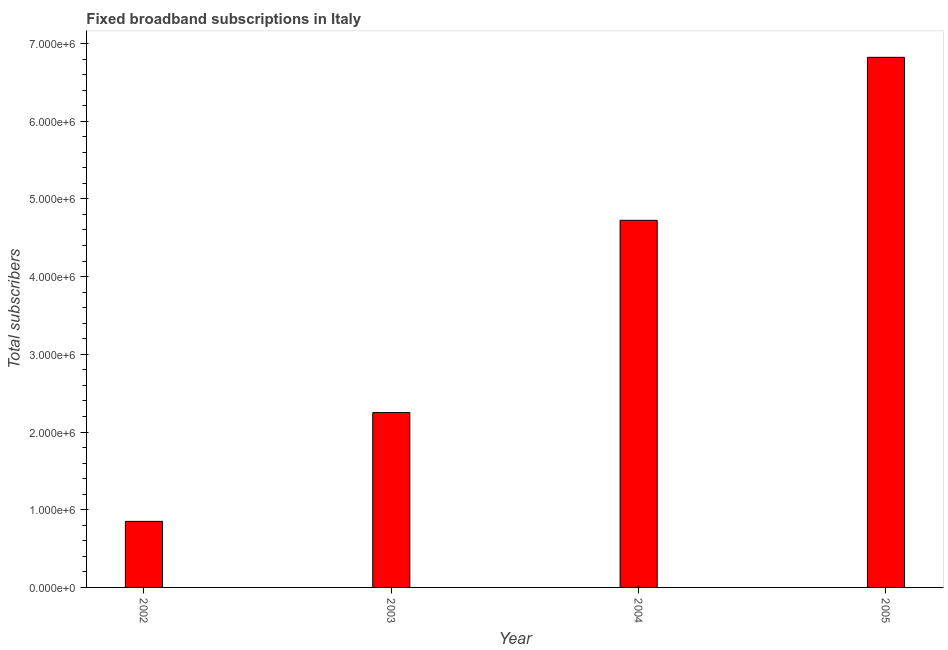What is the title of the graph?
Your answer should be very brief. Fixed broadband subscriptions in Italy. What is the label or title of the Y-axis?
Make the answer very short. Total subscribers. What is the total number of fixed broadband subscriptions in 2004?
Make the answer very short. 4.72e+06. Across all years, what is the maximum total number of fixed broadband subscriptions?
Give a very brief answer. 6.82e+06. Across all years, what is the minimum total number of fixed broadband subscriptions?
Your response must be concise. 8.50e+05. What is the sum of the total number of fixed broadband subscriptions?
Give a very brief answer. 1.46e+07. What is the difference between the total number of fixed broadband subscriptions in 2003 and 2005?
Provide a succinct answer. -4.57e+06. What is the average total number of fixed broadband subscriptions per year?
Your response must be concise. 3.66e+06. What is the median total number of fixed broadband subscriptions?
Offer a terse response. 3.49e+06. In how many years, is the total number of fixed broadband subscriptions greater than 6800000 ?
Your answer should be compact. 1. Do a majority of the years between 2002 and 2003 (inclusive) have total number of fixed broadband subscriptions greater than 4200000 ?
Your answer should be compact. No. What is the ratio of the total number of fixed broadband subscriptions in 2003 to that in 2005?
Give a very brief answer. 0.33. Is the total number of fixed broadband subscriptions in 2004 less than that in 2005?
Offer a very short reply. Yes. Is the difference between the total number of fixed broadband subscriptions in 2002 and 2003 greater than the difference between any two years?
Provide a short and direct response. No. What is the difference between the highest and the second highest total number of fixed broadband subscriptions?
Give a very brief answer. 2.10e+06. Is the sum of the total number of fixed broadband subscriptions in 2002 and 2003 greater than the maximum total number of fixed broadband subscriptions across all years?
Provide a short and direct response. No. What is the difference between the highest and the lowest total number of fixed broadband subscriptions?
Provide a succinct answer. 5.97e+06. How many bars are there?
Give a very brief answer. 4. How many years are there in the graph?
Provide a succinct answer. 4. Are the values on the major ticks of Y-axis written in scientific E-notation?
Your response must be concise. Yes. What is the Total subscribers in 2002?
Offer a terse response. 8.50e+05. What is the Total subscribers in 2003?
Keep it short and to the point. 2.25e+06. What is the Total subscribers of 2004?
Your answer should be compact. 4.72e+06. What is the Total subscribers of 2005?
Your response must be concise. 6.82e+06. What is the difference between the Total subscribers in 2002 and 2003?
Your answer should be very brief. -1.40e+06. What is the difference between the Total subscribers in 2002 and 2004?
Provide a succinct answer. -3.87e+06. What is the difference between the Total subscribers in 2002 and 2005?
Offer a very short reply. -5.97e+06. What is the difference between the Total subscribers in 2003 and 2004?
Give a very brief answer. -2.47e+06. What is the difference between the Total subscribers in 2003 and 2005?
Give a very brief answer. -4.57e+06. What is the difference between the Total subscribers in 2004 and 2005?
Provide a short and direct response. -2.10e+06. What is the ratio of the Total subscribers in 2002 to that in 2003?
Offer a very short reply. 0.38. What is the ratio of the Total subscribers in 2002 to that in 2004?
Your response must be concise. 0.18. What is the ratio of the Total subscribers in 2003 to that in 2004?
Provide a succinct answer. 0.48. What is the ratio of the Total subscribers in 2003 to that in 2005?
Offer a very short reply. 0.33. What is the ratio of the Total subscribers in 2004 to that in 2005?
Your answer should be very brief. 0.69. 